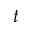<formula> <loc_0><loc_0><loc_500><loc_500>t</formula> 